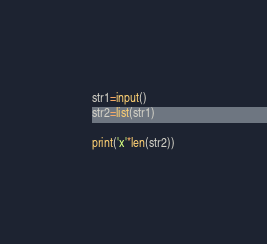Convert code to text. <code><loc_0><loc_0><loc_500><loc_500><_Python_>str1=input()
str2=list(str1)

print('x'*len(str2))</code> 